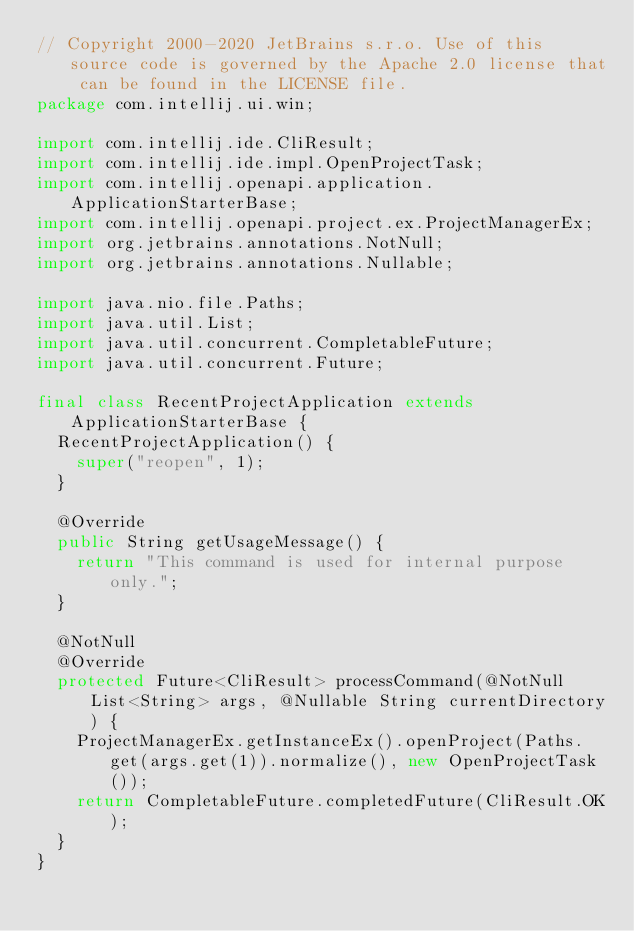Convert code to text. <code><loc_0><loc_0><loc_500><loc_500><_Java_>// Copyright 2000-2020 JetBrains s.r.o. Use of this source code is governed by the Apache 2.0 license that can be found in the LICENSE file.
package com.intellij.ui.win;

import com.intellij.ide.CliResult;
import com.intellij.ide.impl.OpenProjectTask;
import com.intellij.openapi.application.ApplicationStarterBase;
import com.intellij.openapi.project.ex.ProjectManagerEx;
import org.jetbrains.annotations.NotNull;
import org.jetbrains.annotations.Nullable;

import java.nio.file.Paths;
import java.util.List;
import java.util.concurrent.CompletableFuture;
import java.util.concurrent.Future;

final class RecentProjectApplication extends ApplicationStarterBase {
  RecentProjectApplication() {
    super("reopen", 1);
  }

  @Override
  public String getUsageMessage() {
    return "This command is used for internal purpose only.";
  }

  @NotNull
  @Override
  protected Future<CliResult> processCommand(@NotNull List<String> args, @Nullable String currentDirectory) {
    ProjectManagerEx.getInstanceEx().openProject(Paths.get(args.get(1)).normalize(), new OpenProjectTask());
    return CompletableFuture.completedFuture(CliResult.OK);
  }
}</code> 